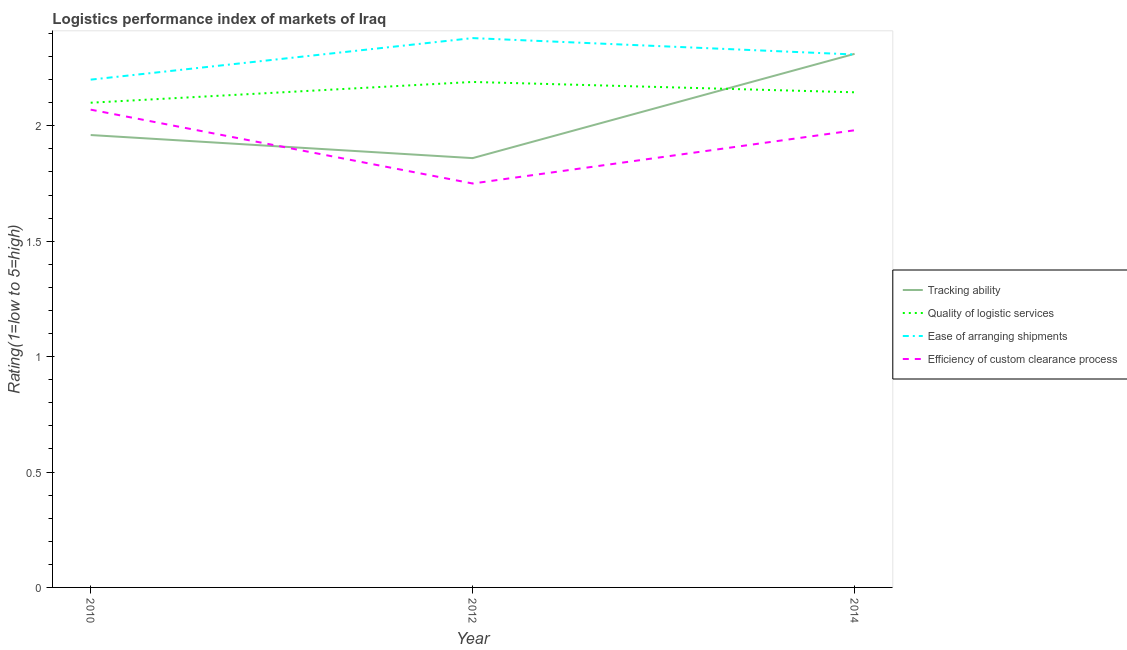Does the line corresponding to lpi rating of tracking ability intersect with the line corresponding to lpi rating of quality of logistic services?
Keep it short and to the point. Yes. Is the number of lines equal to the number of legend labels?
Provide a short and direct response. Yes. What is the lpi rating of quality of logistic services in 2014?
Make the answer very short. 2.15. Across all years, what is the maximum lpi rating of ease of arranging shipments?
Give a very brief answer. 2.38. Across all years, what is the minimum lpi rating of tracking ability?
Your answer should be compact. 1.86. In which year was the lpi rating of quality of logistic services minimum?
Ensure brevity in your answer.  2010. What is the total lpi rating of quality of logistic services in the graph?
Your answer should be compact. 6.44. What is the difference between the lpi rating of tracking ability in 2010 and that in 2014?
Your answer should be very brief. -0.35. What is the difference between the lpi rating of quality of logistic services in 2014 and the lpi rating of tracking ability in 2010?
Provide a short and direct response. 0.19. What is the average lpi rating of ease of arranging shipments per year?
Your answer should be very brief. 2.3. In the year 2012, what is the difference between the lpi rating of quality of logistic services and lpi rating of ease of arranging shipments?
Provide a succinct answer. -0.19. What is the ratio of the lpi rating of efficiency of custom clearance process in 2010 to that in 2012?
Make the answer very short. 1.18. What is the difference between the highest and the second highest lpi rating of ease of arranging shipments?
Make the answer very short. 0.07. What is the difference between the highest and the lowest lpi rating of ease of arranging shipments?
Offer a terse response. 0.18. Is the sum of the lpi rating of quality of logistic services in 2012 and 2014 greater than the maximum lpi rating of ease of arranging shipments across all years?
Provide a short and direct response. Yes. Is the lpi rating of ease of arranging shipments strictly greater than the lpi rating of quality of logistic services over the years?
Offer a terse response. Yes. How many years are there in the graph?
Your answer should be very brief. 3. What is the difference between two consecutive major ticks on the Y-axis?
Your answer should be very brief. 0.5. Are the values on the major ticks of Y-axis written in scientific E-notation?
Make the answer very short. No. Where does the legend appear in the graph?
Your response must be concise. Center right. How are the legend labels stacked?
Offer a very short reply. Vertical. What is the title of the graph?
Ensure brevity in your answer.  Logistics performance index of markets of Iraq. Does "Macroeconomic management" appear as one of the legend labels in the graph?
Make the answer very short. No. What is the label or title of the X-axis?
Your answer should be compact. Year. What is the label or title of the Y-axis?
Keep it short and to the point. Rating(1=low to 5=high). What is the Rating(1=low to 5=high) in Tracking ability in 2010?
Provide a short and direct response. 1.96. What is the Rating(1=low to 5=high) in Quality of logistic services in 2010?
Your answer should be compact. 2.1. What is the Rating(1=low to 5=high) of Efficiency of custom clearance process in 2010?
Give a very brief answer. 2.07. What is the Rating(1=low to 5=high) in Tracking ability in 2012?
Offer a terse response. 1.86. What is the Rating(1=low to 5=high) in Quality of logistic services in 2012?
Offer a terse response. 2.19. What is the Rating(1=low to 5=high) in Ease of arranging shipments in 2012?
Your answer should be compact. 2.38. What is the Rating(1=low to 5=high) in Efficiency of custom clearance process in 2012?
Provide a short and direct response. 1.75. What is the Rating(1=low to 5=high) of Tracking ability in 2014?
Make the answer very short. 2.31. What is the Rating(1=low to 5=high) in Quality of logistic services in 2014?
Your answer should be very brief. 2.15. What is the Rating(1=low to 5=high) in Ease of arranging shipments in 2014?
Offer a terse response. 2.31. What is the Rating(1=low to 5=high) in Efficiency of custom clearance process in 2014?
Keep it short and to the point. 1.98. Across all years, what is the maximum Rating(1=low to 5=high) in Tracking ability?
Make the answer very short. 2.31. Across all years, what is the maximum Rating(1=low to 5=high) of Quality of logistic services?
Ensure brevity in your answer.  2.19. Across all years, what is the maximum Rating(1=low to 5=high) of Ease of arranging shipments?
Your response must be concise. 2.38. Across all years, what is the maximum Rating(1=low to 5=high) in Efficiency of custom clearance process?
Your answer should be very brief. 2.07. Across all years, what is the minimum Rating(1=low to 5=high) in Tracking ability?
Provide a short and direct response. 1.86. Across all years, what is the minimum Rating(1=low to 5=high) of Quality of logistic services?
Your response must be concise. 2.1. What is the total Rating(1=low to 5=high) of Tracking ability in the graph?
Make the answer very short. 6.13. What is the total Rating(1=low to 5=high) in Quality of logistic services in the graph?
Provide a succinct answer. 6.44. What is the total Rating(1=low to 5=high) of Ease of arranging shipments in the graph?
Offer a very short reply. 6.89. What is the total Rating(1=low to 5=high) of Efficiency of custom clearance process in the graph?
Your answer should be compact. 5.8. What is the difference between the Rating(1=low to 5=high) in Tracking ability in 2010 and that in 2012?
Ensure brevity in your answer.  0.1. What is the difference between the Rating(1=low to 5=high) in Quality of logistic services in 2010 and that in 2012?
Your answer should be very brief. -0.09. What is the difference between the Rating(1=low to 5=high) in Ease of arranging shipments in 2010 and that in 2012?
Offer a very short reply. -0.18. What is the difference between the Rating(1=low to 5=high) of Efficiency of custom clearance process in 2010 and that in 2012?
Your answer should be very brief. 0.32. What is the difference between the Rating(1=low to 5=high) in Tracking ability in 2010 and that in 2014?
Keep it short and to the point. -0.35. What is the difference between the Rating(1=low to 5=high) in Quality of logistic services in 2010 and that in 2014?
Provide a succinct answer. -0.05. What is the difference between the Rating(1=low to 5=high) in Ease of arranging shipments in 2010 and that in 2014?
Your answer should be compact. -0.11. What is the difference between the Rating(1=low to 5=high) of Efficiency of custom clearance process in 2010 and that in 2014?
Ensure brevity in your answer.  0.09. What is the difference between the Rating(1=low to 5=high) of Tracking ability in 2012 and that in 2014?
Your response must be concise. -0.45. What is the difference between the Rating(1=low to 5=high) in Quality of logistic services in 2012 and that in 2014?
Keep it short and to the point. 0.04. What is the difference between the Rating(1=low to 5=high) of Ease of arranging shipments in 2012 and that in 2014?
Keep it short and to the point. 0.07. What is the difference between the Rating(1=low to 5=high) in Efficiency of custom clearance process in 2012 and that in 2014?
Offer a very short reply. -0.23. What is the difference between the Rating(1=low to 5=high) in Tracking ability in 2010 and the Rating(1=low to 5=high) in Quality of logistic services in 2012?
Offer a very short reply. -0.23. What is the difference between the Rating(1=low to 5=high) in Tracking ability in 2010 and the Rating(1=low to 5=high) in Ease of arranging shipments in 2012?
Provide a succinct answer. -0.42. What is the difference between the Rating(1=low to 5=high) of Tracking ability in 2010 and the Rating(1=low to 5=high) of Efficiency of custom clearance process in 2012?
Give a very brief answer. 0.21. What is the difference between the Rating(1=low to 5=high) in Quality of logistic services in 2010 and the Rating(1=low to 5=high) in Ease of arranging shipments in 2012?
Offer a very short reply. -0.28. What is the difference between the Rating(1=low to 5=high) in Ease of arranging shipments in 2010 and the Rating(1=low to 5=high) in Efficiency of custom clearance process in 2012?
Your answer should be compact. 0.45. What is the difference between the Rating(1=low to 5=high) in Tracking ability in 2010 and the Rating(1=low to 5=high) in Quality of logistic services in 2014?
Your answer should be compact. -0.19. What is the difference between the Rating(1=low to 5=high) of Tracking ability in 2010 and the Rating(1=low to 5=high) of Ease of arranging shipments in 2014?
Provide a short and direct response. -0.35. What is the difference between the Rating(1=low to 5=high) of Tracking ability in 2010 and the Rating(1=low to 5=high) of Efficiency of custom clearance process in 2014?
Your response must be concise. -0.02. What is the difference between the Rating(1=low to 5=high) of Quality of logistic services in 2010 and the Rating(1=low to 5=high) of Ease of arranging shipments in 2014?
Ensure brevity in your answer.  -0.21. What is the difference between the Rating(1=low to 5=high) of Quality of logistic services in 2010 and the Rating(1=low to 5=high) of Efficiency of custom clearance process in 2014?
Give a very brief answer. 0.12. What is the difference between the Rating(1=low to 5=high) of Ease of arranging shipments in 2010 and the Rating(1=low to 5=high) of Efficiency of custom clearance process in 2014?
Keep it short and to the point. 0.22. What is the difference between the Rating(1=low to 5=high) in Tracking ability in 2012 and the Rating(1=low to 5=high) in Quality of logistic services in 2014?
Keep it short and to the point. -0.29. What is the difference between the Rating(1=low to 5=high) of Tracking ability in 2012 and the Rating(1=low to 5=high) of Ease of arranging shipments in 2014?
Ensure brevity in your answer.  -0.45. What is the difference between the Rating(1=low to 5=high) in Tracking ability in 2012 and the Rating(1=low to 5=high) in Efficiency of custom clearance process in 2014?
Give a very brief answer. -0.12. What is the difference between the Rating(1=low to 5=high) of Quality of logistic services in 2012 and the Rating(1=low to 5=high) of Ease of arranging shipments in 2014?
Provide a succinct answer. -0.12. What is the difference between the Rating(1=low to 5=high) of Quality of logistic services in 2012 and the Rating(1=low to 5=high) of Efficiency of custom clearance process in 2014?
Keep it short and to the point. 0.21. What is the difference between the Rating(1=low to 5=high) in Ease of arranging shipments in 2012 and the Rating(1=low to 5=high) in Efficiency of custom clearance process in 2014?
Offer a very short reply. 0.4. What is the average Rating(1=low to 5=high) of Tracking ability per year?
Give a very brief answer. 2.04. What is the average Rating(1=low to 5=high) in Quality of logistic services per year?
Provide a short and direct response. 2.15. What is the average Rating(1=low to 5=high) of Ease of arranging shipments per year?
Your answer should be very brief. 2.3. What is the average Rating(1=low to 5=high) of Efficiency of custom clearance process per year?
Give a very brief answer. 1.93. In the year 2010, what is the difference between the Rating(1=low to 5=high) in Tracking ability and Rating(1=low to 5=high) in Quality of logistic services?
Keep it short and to the point. -0.14. In the year 2010, what is the difference between the Rating(1=low to 5=high) in Tracking ability and Rating(1=low to 5=high) in Ease of arranging shipments?
Offer a terse response. -0.24. In the year 2010, what is the difference between the Rating(1=low to 5=high) of Tracking ability and Rating(1=low to 5=high) of Efficiency of custom clearance process?
Provide a succinct answer. -0.11. In the year 2010, what is the difference between the Rating(1=low to 5=high) in Quality of logistic services and Rating(1=low to 5=high) in Ease of arranging shipments?
Your answer should be very brief. -0.1. In the year 2010, what is the difference between the Rating(1=low to 5=high) of Ease of arranging shipments and Rating(1=low to 5=high) of Efficiency of custom clearance process?
Offer a terse response. 0.13. In the year 2012, what is the difference between the Rating(1=low to 5=high) in Tracking ability and Rating(1=low to 5=high) in Quality of logistic services?
Offer a very short reply. -0.33. In the year 2012, what is the difference between the Rating(1=low to 5=high) in Tracking ability and Rating(1=low to 5=high) in Ease of arranging shipments?
Keep it short and to the point. -0.52. In the year 2012, what is the difference between the Rating(1=low to 5=high) of Tracking ability and Rating(1=low to 5=high) of Efficiency of custom clearance process?
Your response must be concise. 0.11. In the year 2012, what is the difference between the Rating(1=low to 5=high) of Quality of logistic services and Rating(1=low to 5=high) of Ease of arranging shipments?
Provide a short and direct response. -0.19. In the year 2012, what is the difference between the Rating(1=low to 5=high) of Quality of logistic services and Rating(1=low to 5=high) of Efficiency of custom clearance process?
Your response must be concise. 0.44. In the year 2012, what is the difference between the Rating(1=low to 5=high) in Ease of arranging shipments and Rating(1=low to 5=high) in Efficiency of custom clearance process?
Give a very brief answer. 0.63. In the year 2014, what is the difference between the Rating(1=low to 5=high) of Tracking ability and Rating(1=low to 5=high) of Quality of logistic services?
Give a very brief answer. 0.17. In the year 2014, what is the difference between the Rating(1=low to 5=high) in Tracking ability and Rating(1=low to 5=high) in Ease of arranging shipments?
Offer a very short reply. 0. In the year 2014, what is the difference between the Rating(1=low to 5=high) in Tracking ability and Rating(1=low to 5=high) in Efficiency of custom clearance process?
Offer a very short reply. 0.33. In the year 2014, what is the difference between the Rating(1=low to 5=high) in Quality of logistic services and Rating(1=low to 5=high) in Ease of arranging shipments?
Offer a terse response. -0.16. In the year 2014, what is the difference between the Rating(1=low to 5=high) of Quality of logistic services and Rating(1=low to 5=high) of Efficiency of custom clearance process?
Keep it short and to the point. 0.16. In the year 2014, what is the difference between the Rating(1=low to 5=high) of Ease of arranging shipments and Rating(1=low to 5=high) of Efficiency of custom clearance process?
Your response must be concise. 0.33. What is the ratio of the Rating(1=low to 5=high) in Tracking ability in 2010 to that in 2012?
Provide a short and direct response. 1.05. What is the ratio of the Rating(1=low to 5=high) in Quality of logistic services in 2010 to that in 2012?
Make the answer very short. 0.96. What is the ratio of the Rating(1=low to 5=high) of Ease of arranging shipments in 2010 to that in 2012?
Provide a succinct answer. 0.92. What is the ratio of the Rating(1=low to 5=high) in Efficiency of custom clearance process in 2010 to that in 2012?
Provide a succinct answer. 1.18. What is the ratio of the Rating(1=low to 5=high) in Tracking ability in 2010 to that in 2014?
Offer a terse response. 0.85. What is the ratio of the Rating(1=low to 5=high) in Quality of logistic services in 2010 to that in 2014?
Provide a succinct answer. 0.98. What is the ratio of the Rating(1=low to 5=high) in Ease of arranging shipments in 2010 to that in 2014?
Your response must be concise. 0.95. What is the ratio of the Rating(1=low to 5=high) of Efficiency of custom clearance process in 2010 to that in 2014?
Provide a short and direct response. 1.05. What is the ratio of the Rating(1=low to 5=high) of Tracking ability in 2012 to that in 2014?
Your answer should be very brief. 0.8. What is the ratio of the Rating(1=low to 5=high) in Quality of logistic services in 2012 to that in 2014?
Your answer should be compact. 1.02. What is the ratio of the Rating(1=low to 5=high) in Ease of arranging shipments in 2012 to that in 2014?
Your answer should be very brief. 1.03. What is the ratio of the Rating(1=low to 5=high) in Efficiency of custom clearance process in 2012 to that in 2014?
Give a very brief answer. 0.88. What is the difference between the highest and the second highest Rating(1=low to 5=high) in Tracking ability?
Make the answer very short. 0.35. What is the difference between the highest and the second highest Rating(1=low to 5=high) of Quality of logistic services?
Your answer should be very brief. 0.04. What is the difference between the highest and the second highest Rating(1=low to 5=high) of Ease of arranging shipments?
Give a very brief answer. 0.07. What is the difference between the highest and the second highest Rating(1=low to 5=high) of Efficiency of custom clearance process?
Provide a succinct answer. 0.09. What is the difference between the highest and the lowest Rating(1=low to 5=high) in Tracking ability?
Provide a short and direct response. 0.45. What is the difference between the highest and the lowest Rating(1=low to 5=high) of Quality of logistic services?
Keep it short and to the point. 0.09. What is the difference between the highest and the lowest Rating(1=low to 5=high) in Ease of arranging shipments?
Keep it short and to the point. 0.18. What is the difference between the highest and the lowest Rating(1=low to 5=high) of Efficiency of custom clearance process?
Offer a terse response. 0.32. 